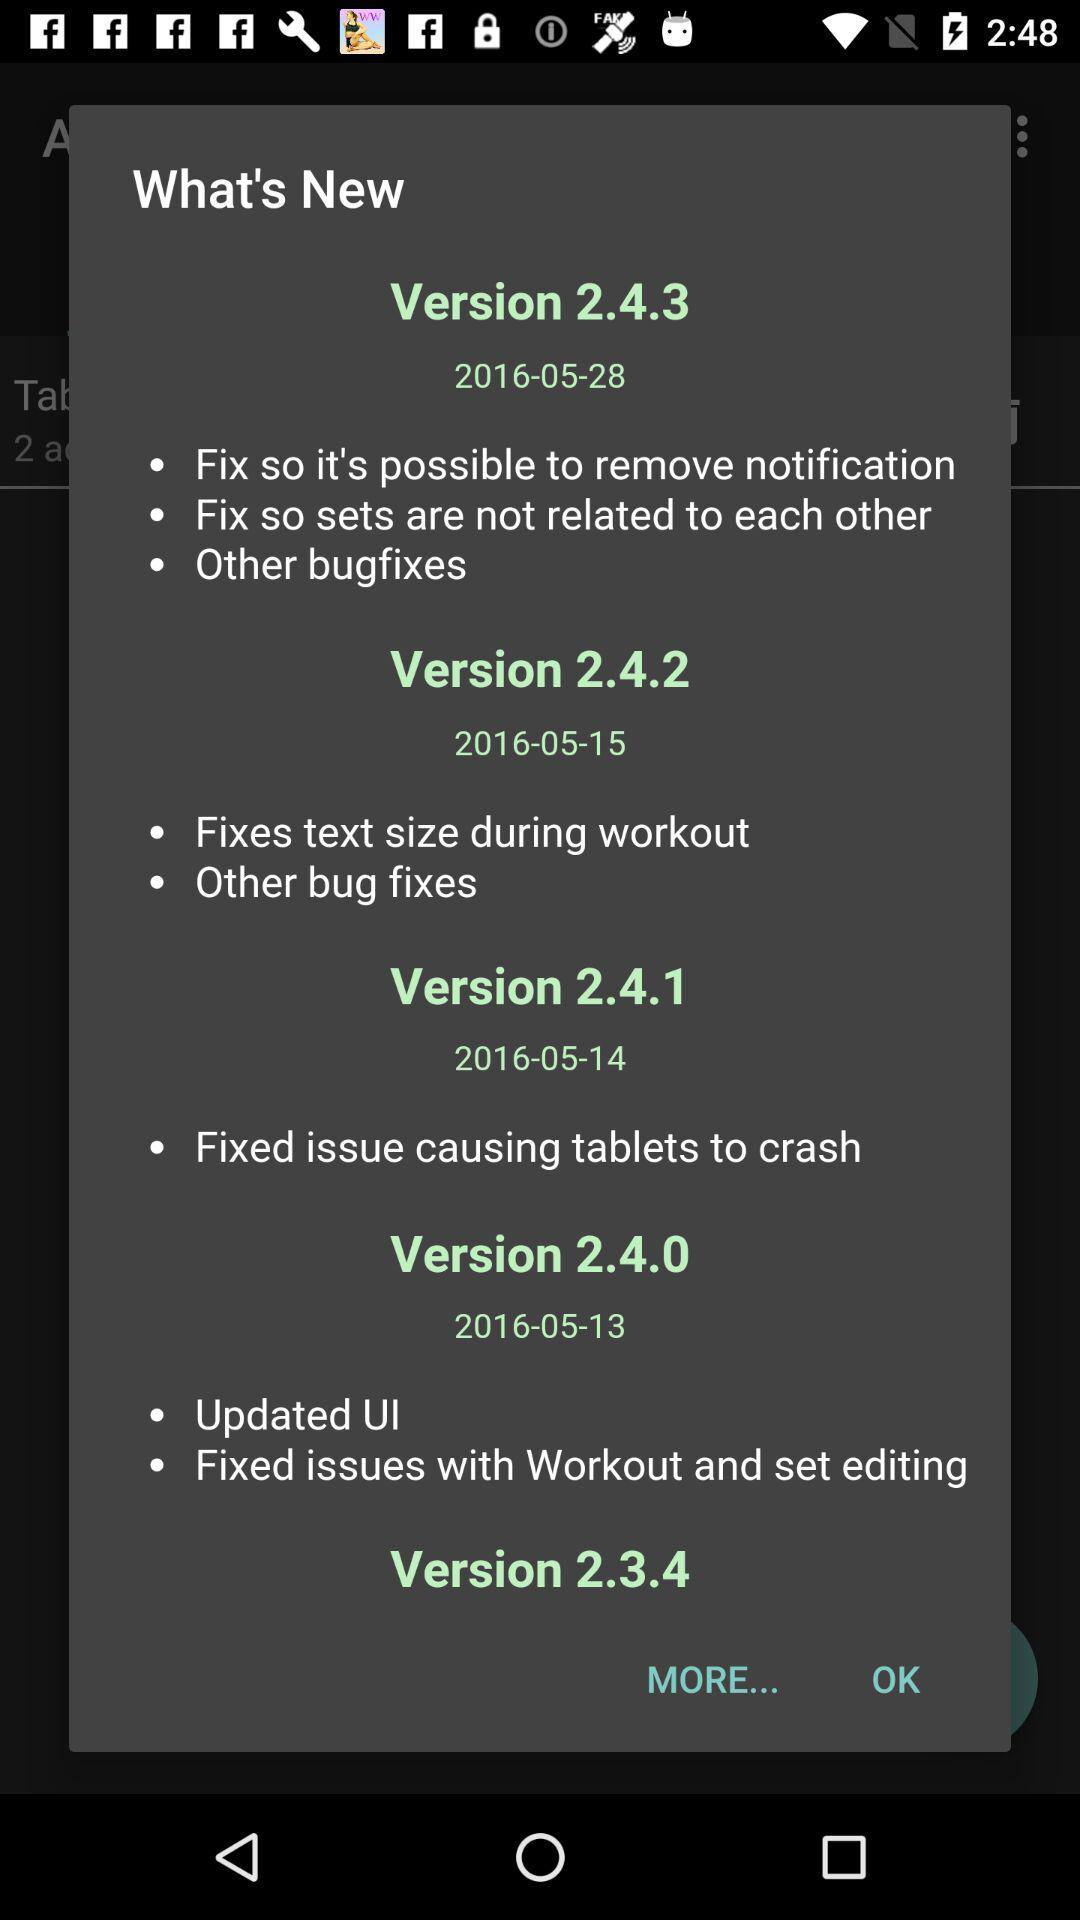What date is shown in version 2.4.3? The date shown in version 2.4.3 is May 28, 2016. 